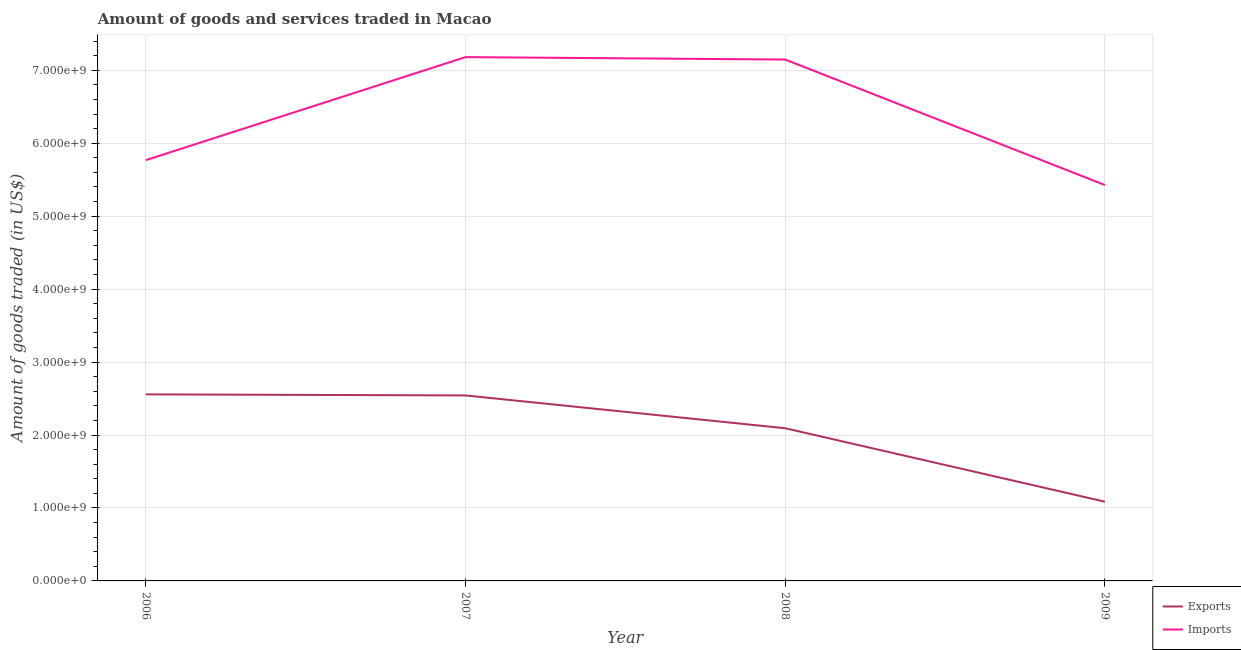How many different coloured lines are there?
Provide a short and direct response. 2. What is the amount of goods exported in 2006?
Offer a very short reply. 2.56e+09. Across all years, what is the maximum amount of goods imported?
Offer a terse response. 7.18e+09. Across all years, what is the minimum amount of goods exported?
Ensure brevity in your answer.  1.09e+09. In which year was the amount of goods exported maximum?
Your response must be concise. 2006. What is the total amount of goods exported in the graph?
Give a very brief answer. 8.28e+09. What is the difference between the amount of goods exported in 2006 and that in 2009?
Provide a succinct answer. 1.47e+09. What is the difference between the amount of goods imported in 2007 and the amount of goods exported in 2008?
Give a very brief answer. 5.09e+09. What is the average amount of goods exported per year?
Provide a succinct answer. 2.07e+09. In the year 2007, what is the difference between the amount of goods imported and amount of goods exported?
Offer a terse response. 4.64e+09. What is the ratio of the amount of goods imported in 2006 to that in 2009?
Your answer should be very brief. 1.06. What is the difference between the highest and the second highest amount of goods exported?
Provide a short and direct response. 1.48e+07. What is the difference between the highest and the lowest amount of goods exported?
Offer a terse response. 1.47e+09. Is the sum of the amount of goods imported in 2006 and 2008 greater than the maximum amount of goods exported across all years?
Keep it short and to the point. Yes. Is the amount of goods imported strictly greater than the amount of goods exported over the years?
Your response must be concise. Yes. Is the amount of goods exported strictly less than the amount of goods imported over the years?
Make the answer very short. Yes. How many years are there in the graph?
Offer a terse response. 4. What is the difference between two consecutive major ticks on the Y-axis?
Offer a very short reply. 1.00e+09. Does the graph contain grids?
Your answer should be compact. Yes. How many legend labels are there?
Provide a short and direct response. 2. How are the legend labels stacked?
Ensure brevity in your answer.  Vertical. What is the title of the graph?
Your answer should be compact. Amount of goods and services traded in Macao. Does "Fixed telephone" appear as one of the legend labels in the graph?
Give a very brief answer. No. What is the label or title of the X-axis?
Your response must be concise. Year. What is the label or title of the Y-axis?
Ensure brevity in your answer.  Amount of goods traded (in US$). What is the Amount of goods traded (in US$) in Exports in 2006?
Provide a short and direct response. 2.56e+09. What is the Amount of goods traded (in US$) in Imports in 2006?
Your answer should be very brief. 5.77e+09. What is the Amount of goods traded (in US$) of Exports in 2007?
Give a very brief answer. 2.54e+09. What is the Amount of goods traded (in US$) of Imports in 2007?
Keep it short and to the point. 7.18e+09. What is the Amount of goods traded (in US$) of Exports in 2008?
Keep it short and to the point. 2.09e+09. What is the Amount of goods traded (in US$) of Imports in 2008?
Your answer should be very brief. 7.15e+09. What is the Amount of goods traded (in US$) in Exports in 2009?
Your response must be concise. 1.09e+09. What is the Amount of goods traded (in US$) of Imports in 2009?
Give a very brief answer. 5.43e+09. Across all years, what is the maximum Amount of goods traded (in US$) in Exports?
Offer a terse response. 2.56e+09. Across all years, what is the maximum Amount of goods traded (in US$) in Imports?
Offer a very short reply. 7.18e+09. Across all years, what is the minimum Amount of goods traded (in US$) of Exports?
Offer a very short reply. 1.09e+09. Across all years, what is the minimum Amount of goods traded (in US$) of Imports?
Offer a very short reply. 5.43e+09. What is the total Amount of goods traded (in US$) in Exports in the graph?
Make the answer very short. 8.28e+09. What is the total Amount of goods traded (in US$) in Imports in the graph?
Your response must be concise. 2.55e+1. What is the difference between the Amount of goods traded (in US$) of Exports in 2006 and that in 2007?
Keep it short and to the point. 1.48e+07. What is the difference between the Amount of goods traded (in US$) of Imports in 2006 and that in 2007?
Your answer should be compact. -1.41e+09. What is the difference between the Amount of goods traded (in US$) of Exports in 2006 and that in 2008?
Offer a terse response. 4.64e+08. What is the difference between the Amount of goods traded (in US$) in Imports in 2006 and that in 2008?
Your response must be concise. -1.38e+09. What is the difference between the Amount of goods traded (in US$) of Exports in 2006 and that in 2009?
Your response must be concise. 1.47e+09. What is the difference between the Amount of goods traded (in US$) of Imports in 2006 and that in 2009?
Your answer should be compact. 3.42e+08. What is the difference between the Amount of goods traded (in US$) in Exports in 2007 and that in 2008?
Your response must be concise. 4.49e+08. What is the difference between the Amount of goods traded (in US$) of Imports in 2007 and that in 2008?
Make the answer very short. 3.35e+07. What is the difference between the Amount of goods traded (in US$) in Exports in 2007 and that in 2009?
Offer a terse response. 1.46e+09. What is the difference between the Amount of goods traded (in US$) of Imports in 2007 and that in 2009?
Provide a succinct answer. 1.75e+09. What is the difference between the Amount of goods traded (in US$) in Exports in 2008 and that in 2009?
Give a very brief answer. 1.01e+09. What is the difference between the Amount of goods traded (in US$) in Imports in 2008 and that in 2009?
Offer a terse response. 1.72e+09. What is the difference between the Amount of goods traded (in US$) of Exports in 2006 and the Amount of goods traded (in US$) of Imports in 2007?
Your answer should be compact. -4.62e+09. What is the difference between the Amount of goods traded (in US$) of Exports in 2006 and the Amount of goods traded (in US$) of Imports in 2008?
Your answer should be very brief. -4.59e+09. What is the difference between the Amount of goods traded (in US$) of Exports in 2006 and the Amount of goods traded (in US$) of Imports in 2009?
Provide a succinct answer. -2.87e+09. What is the difference between the Amount of goods traded (in US$) in Exports in 2007 and the Amount of goods traded (in US$) in Imports in 2008?
Your answer should be compact. -4.60e+09. What is the difference between the Amount of goods traded (in US$) in Exports in 2007 and the Amount of goods traded (in US$) in Imports in 2009?
Keep it short and to the point. -2.88e+09. What is the difference between the Amount of goods traded (in US$) in Exports in 2008 and the Amount of goods traded (in US$) in Imports in 2009?
Your answer should be compact. -3.33e+09. What is the average Amount of goods traded (in US$) of Exports per year?
Ensure brevity in your answer.  2.07e+09. What is the average Amount of goods traded (in US$) in Imports per year?
Make the answer very short. 6.38e+09. In the year 2006, what is the difference between the Amount of goods traded (in US$) of Exports and Amount of goods traded (in US$) of Imports?
Your answer should be very brief. -3.21e+09. In the year 2007, what is the difference between the Amount of goods traded (in US$) of Exports and Amount of goods traded (in US$) of Imports?
Your response must be concise. -4.64e+09. In the year 2008, what is the difference between the Amount of goods traded (in US$) in Exports and Amount of goods traded (in US$) in Imports?
Make the answer very short. -5.05e+09. In the year 2009, what is the difference between the Amount of goods traded (in US$) of Exports and Amount of goods traded (in US$) of Imports?
Offer a terse response. -4.34e+09. What is the ratio of the Amount of goods traded (in US$) of Exports in 2006 to that in 2007?
Your response must be concise. 1.01. What is the ratio of the Amount of goods traded (in US$) in Imports in 2006 to that in 2007?
Provide a succinct answer. 0.8. What is the ratio of the Amount of goods traded (in US$) in Exports in 2006 to that in 2008?
Your answer should be very brief. 1.22. What is the ratio of the Amount of goods traded (in US$) of Imports in 2006 to that in 2008?
Provide a succinct answer. 0.81. What is the ratio of the Amount of goods traded (in US$) of Exports in 2006 to that in 2009?
Your answer should be compact. 2.35. What is the ratio of the Amount of goods traded (in US$) of Imports in 2006 to that in 2009?
Offer a very short reply. 1.06. What is the ratio of the Amount of goods traded (in US$) in Exports in 2007 to that in 2008?
Your answer should be compact. 1.21. What is the ratio of the Amount of goods traded (in US$) in Imports in 2007 to that in 2008?
Make the answer very short. 1. What is the ratio of the Amount of goods traded (in US$) of Exports in 2007 to that in 2009?
Keep it short and to the point. 2.34. What is the ratio of the Amount of goods traded (in US$) in Imports in 2007 to that in 2009?
Offer a very short reply. 1.32. What is the ratio of the Amount of goods traded (in US$) in Exports in 2008 to that in 2009?
Your response must be concise. 1.93. What is the ratio of the Amount of goods traded (in US$) in Imports in 2008 to that in 2009?
Your answer should be compact. 1.32. What is the difference between the highest and the second highest Amount of goods traded (in US$) of Exports?
Offer a terse response. 1.48e+07. What is the difference between the highest and the second highest Amount of goods traded (in US$) of Imports?
Your answer should be compact. 3.35e+07. What is the difference between the highest and the lowest Amount of goods traded (in US$) of Exports?
Give a very brief answer. 1.47e+09. What is the difference between the highest and the lowest Amount of goods traded (in US$) in Imports?
Give a very brief answer. 1.75e+09. 